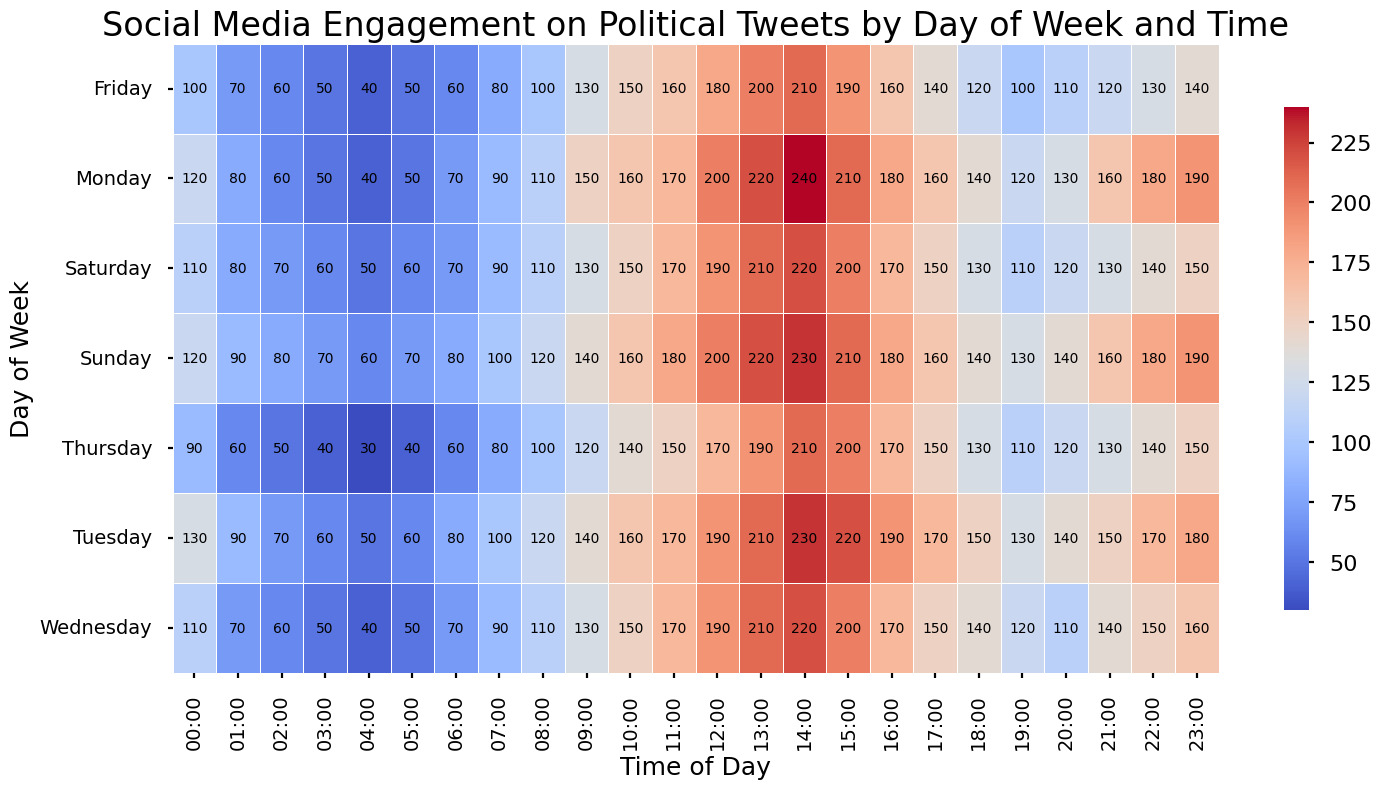Which day of the week has the highest engagement around noon? By looking at the figure, you can notice that Tuesday at 12:00 PM has a value of 190 engagements.
Answer: Tuesday Which time of the day generally has the highest engagement across the week? Observing the figure, the time slot around 1:00 PM (13:00) shows high engagement values across all days.
Answer: 13:00 Are there any days where engagement is consistently low during early morning hours (00:00-05:00)? By checking the figure, Thursday and Friday show consistently lower engagements during early morning hours with values around 30-60.
Answer: Thursday and Friday What is the difference in engagements between the highest value on Monday and the lowest value on Monday? The highest value on Monday is 240 at 2:00 PM (14:00) and the lowest value is 40 at 4:00 AM (04:00), making the difference 240 - 40 = 200.
Answer: 200 On which day does engagement at 9:00 AM (09:00) reach its peak? At 9:00 AM, Monday has the highest engagement at 150.
Answer: Monday Among Friday and Saturday, which day has generally higher engagements in the evening (6:00 PM - 11:00 PM)? Comparing the heatmap for Friday and Saturday during evening hours, Saturday has generally higher engagements compared to Friday with values above 100.
Answer: Saturday What is the average engagement level on Sunday during 12:00 PM (12:00) to 2:00 PM (14:00)? The engagement levels are 200, 220, 230 respectively at 12:00 PM, 1:00 PM, and 2:00 PM. The average is (200 + 220 + 230) / 3 = 650 / 3 ≈ 217.
Answer: 217 Which time period shows a sudden increase in engagement on Wednesday? There is a jump in engagements from 11:00 AM (170) to 12:00 PM (190).
Answer: 11:00 AM to 12:00 PM Which day has the most consistent engagement levels throughout the day? Observing the heatmap, Tuesday has relatively consistent engagement levels throughout different times of the day.
Answer: Tuesday 